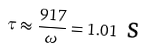Convert formula to latex. <formula><loc_0><loc_0><loc_500><loc_500>\tau \approx \frac { 9 1 7 } { \omega } = 1 . 0 1 \text { s}</formula> 